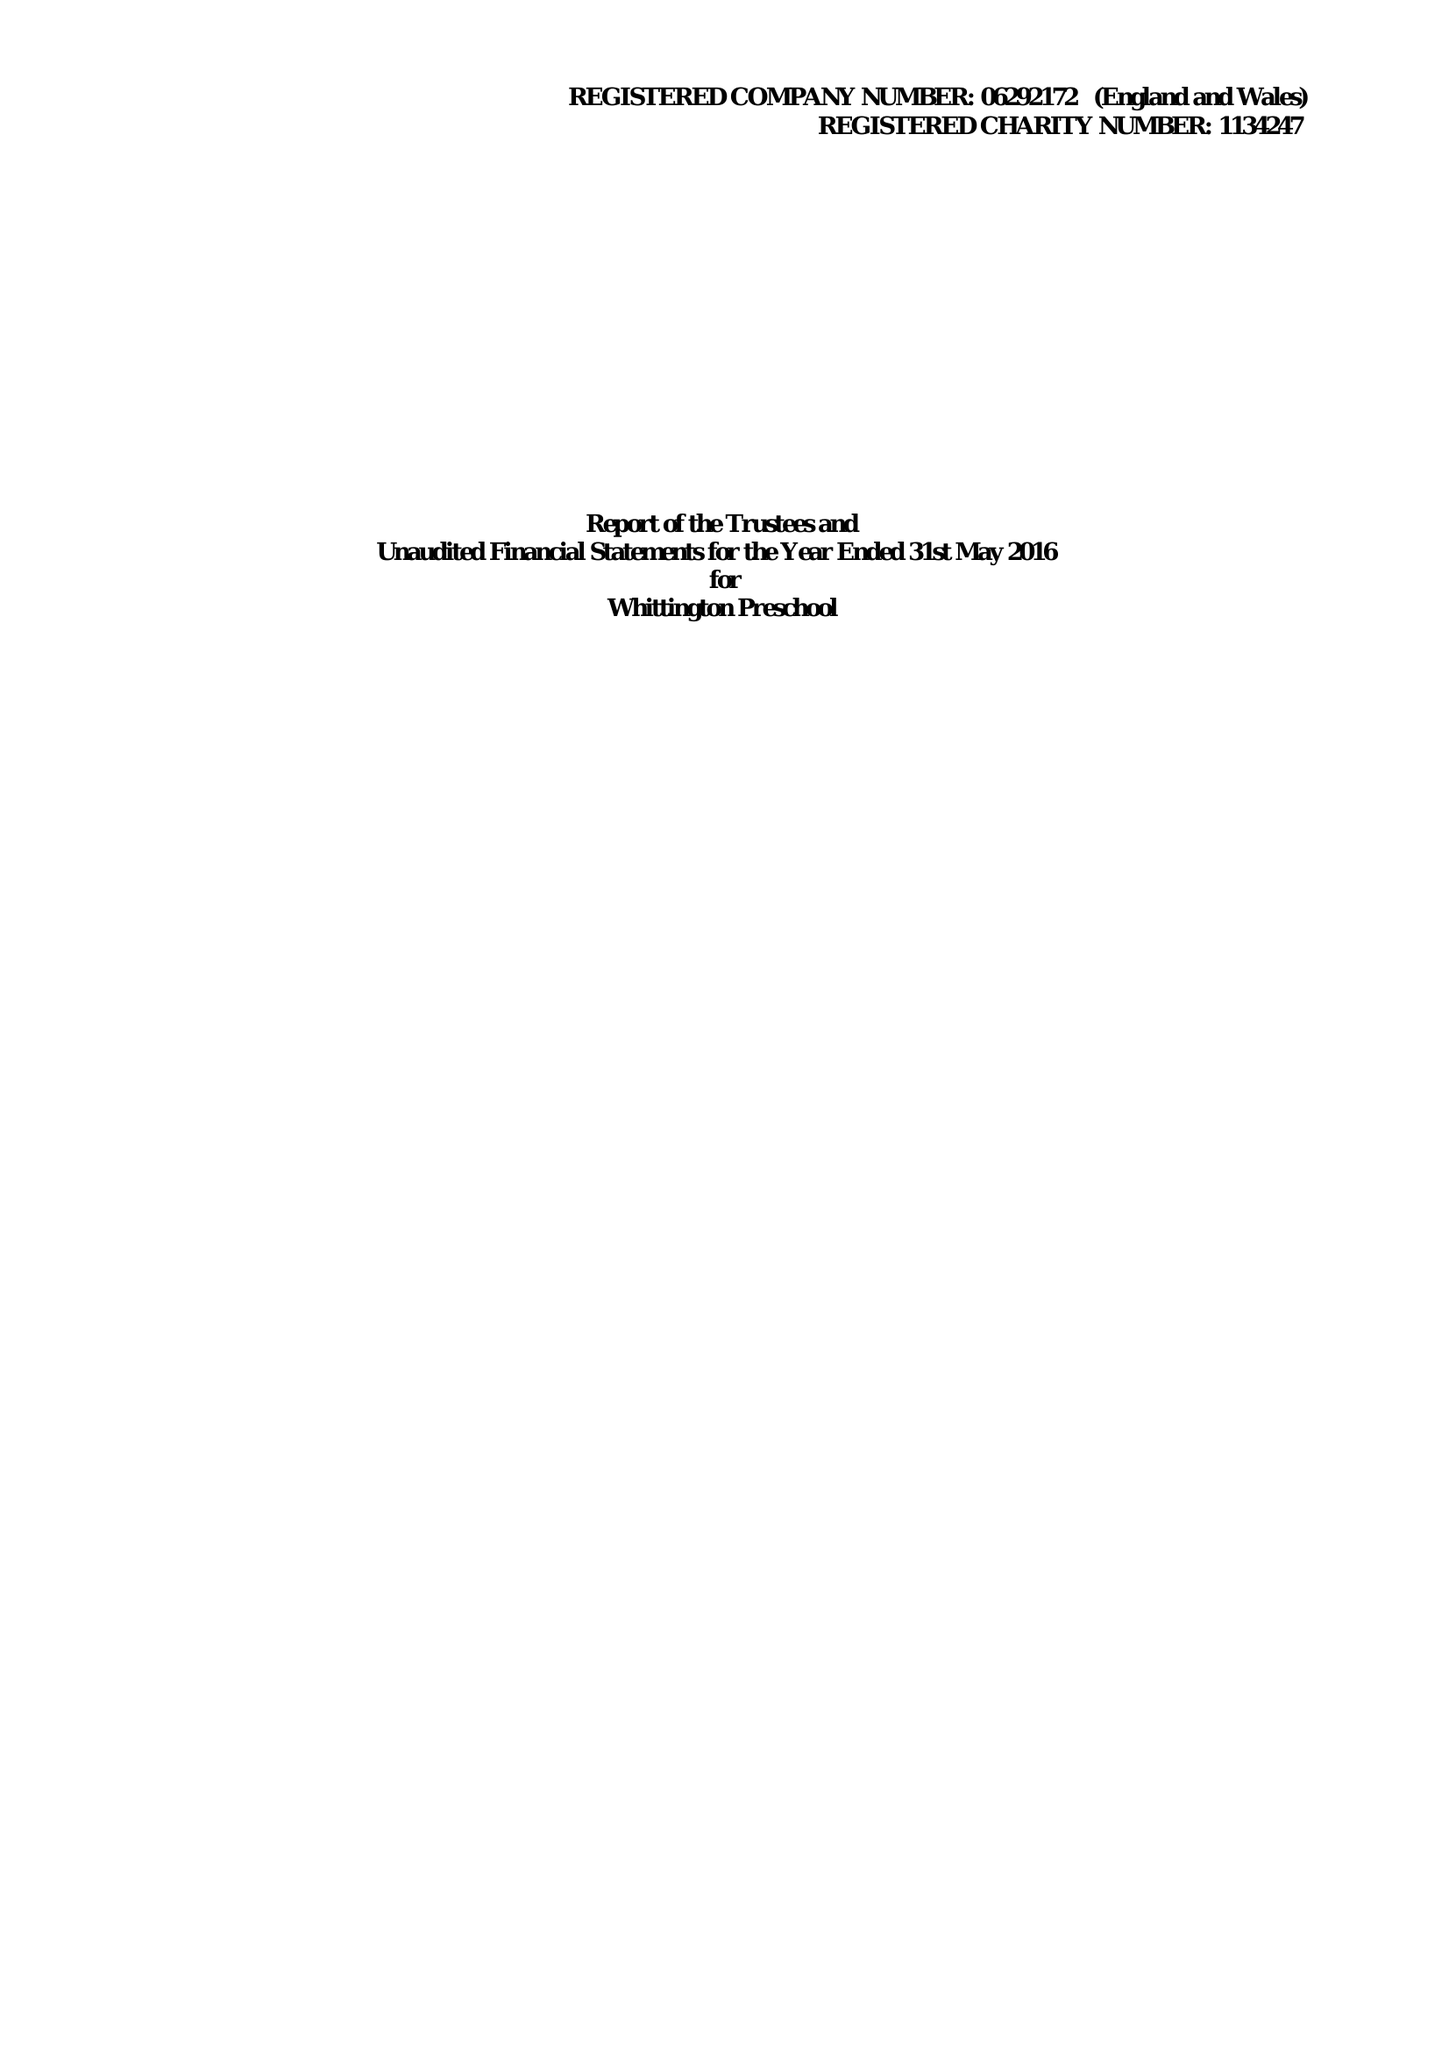What is the value for the address__post_town?
Answer the question using a single word or phrase. LICHFIELD 